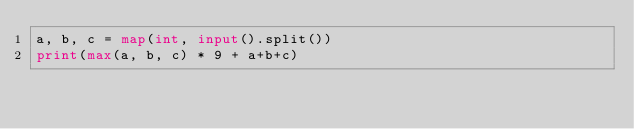Convert code to text. <code><loc_0><loc_0><loc_500><loc_500><_Python_>a, b, c = map(int, input().split())
print(max(a, b, c) * 9 + a+b+c)</code> 